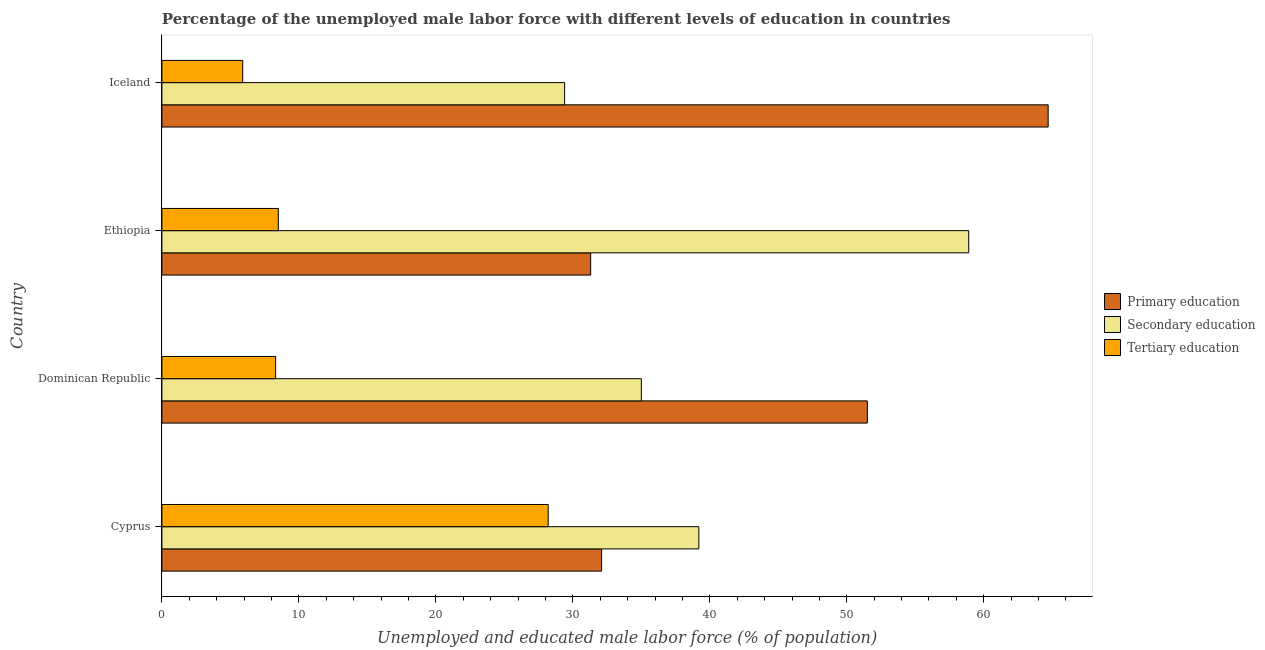How many different coloured bars are there?
Give a very brief answer. 3. How many groups of bars are there?
Give a very brief answer. 4. What is the label of the 3rd group of bars from the top?
Make the answer very short. Dominican Republic. In how many cases, is the number of bars for a given country not equal to the number of legend labels?
Your answer should be very brief. 0. What is the percentage of male labor force who received tertiary education in Dominican Republic?
Offer a very short reply. 8.3. Across all countries, what is the maximum percentage of male labor force who received primary education?
Offer a terse response. 64.7. Across all countries, what is the minimum percentage of male labor force who received tertiary education?
Provide a succinct answer. 5.9. In which country was the percentage of male labor force who received tertiary education maximum?
Your answer should be compact. Cyprus. In which country was the percentage of male labor force who received primary education minimum?
Your answer should be very brief. Ethiopia. What is the total percentage of male labor force who received tertiary education in the graph?
Provide a short and direct response. 50.9. What is the difference between the percentage of male labor force who received secondary education in Dominican Republic and the percentage of male labor force who received primary education in Cyprus?
Make the answer very short. 2.9. What is the average percentage of male labor force who received tertiary education per country?
Your answer should be compact. 12.72. In how many countries, is the percentage of male labor force who received secondary education greater than 10 %?
Your answer should be very brief. 4. What is the difference between the highest and the second highest percentage of male labor force who received secondary education?
Offer a very short reply. 19.7. What is the difference between the highest and the lowest percentage of male labor force who received primary education?
Ensure brevity in your answer.  33.4. What does the 2nd bar from the top in Ethiopia represents?
Your response must be concise. Secondary education. Is it the case that in every country, the sum of the percentage of male labor force who received primary education and percentage of male labor force who received secondary education is greater than the percentage of male labor force who received tertiary education?
Provide a short and direct response. Yes. How many countries are there in the graph?
Provide a short and direct response. 4. Where does the legend appear in the graph?
Make the answer very short. Center right. How are the legend labels stacked?
Your answer should be compact. Vertical. What is the title of the graph?
Ensure brevity in your answer.  Percentage of the unemployed male labor force with different levels of education in countries. Does "Food" appear as one of the legend labels in the graph?
Provide a short and direct response. No. What is the label or title of the X-axis?
Offer a terse response. Unemployed and educated male labor force (% of population). What is the Unemployed and educated male labor force (% of population) in Primary education in Cyprus?
Provide a succinct answer. 32.1. What is the Unemployed and educated male labor force (% of population) in Secondary education in Cyprus?
Your answer should be very brief. 39.2. What is the Unemployed and educated male labor force (% of population) in Tertiary education in Cyprus?
Your answer should be compact. 28.2. What is the Unemployed and educated male labor force (% of population) in Primary education in Dominican Republic?
Offer a very short reply. 51.5. What is the Unemployed and educated male labor force (% of population) of Tertiary education in Dominican Republic?
Provide a short and direct response. 8.3. What is the Unemployed and educated male labor force (% of population) of Primary education in Ethiopia?
Ensure brevity in your answer.  31.3. What is the Unemployed and educated male labor force (% of population) in Secondary education in Ethiopia?
Provide a short and direct response. 58.9. What is the Unemployed and educated male labor force (% of population) of Primary education in Iceland?
Offer a very short reply. 64.7. What is the Unemployed and educated male labor force (% of population) of Secondary education in Iceland?
Offer a terse response. 29.4. What is the Unemployed and educated male labor force (% of population) of Tertiary education in Iceland?
Offer a very short reply. 5.9. Across all countries, what is the maximum Unemployed and educated male labor force (% of population) in Primary education?
Give a very brief answer. 64.7. Across all countries, what is the maximum Unemployed and educated male labor force (% of population) in Secondary education?
Your answer should be compact. 58.9. Across all countries, what is the maximum Unemployed and educated male labor force (% of population) of Tertiary education?
Offer a terse response. 28.2. Across all countries, what is the minimum Unemployed and educated male labor force (% of population) in Primary education?
Provide a short and direct response. 31.3. Across all countries, what is the minimum Unemployed and educated male labor force (% of population) in Secondary education?
Keep it short and to the point. 29.4. Across all countries, what is the minimum Unemployed and educated male labor force (% of population) in Tertiary education?
Make the answer very short. 5.9. What is the total Unemployed and educated male labor force (% of population) of Primary education in the graph?
Provide a short and direct response. 179.6. What is the total Unemployed and educated male labor force (% of population) of Secondary education in the graph?
Ensure brevity in your answer.  162.5. What is the total Unemployed and educated male labor force (% of population) in Tertiary education in the graph?
Your answer should be very brief. 50.9. What is the difference between the Unemployed and educated male labor force (% of population) in Primary education in Cyprus and that in Dominican Republic?
Provide a succinct answer. -19.4. What is the difference between the Unemployed and educated male labor force (% of population) in Secondary education in Cyprus and that in Dominican Republic?
Make the answer very short. 4.2. What is the difference between the Unemployed and educated male labor force (% of population) of Secondary education in Cyprus and that in Ethiopia?
Make the answer very short. -19.7. What is the difference between the Unemployed and educated male labor force (% of population) in Tertiary education in Cyprus and that in Ethiopia?
Provide a succinct answer. 19.7. What is the difference between the Unemployed and educated male labor force (% of population) in Primary education in Cyprus and that in Iceland?
Offer a very short reply. -32.6. What is the difference between the Unemployed and educated male labor force (% of population) of Tertiary education in Cyprus and that in Iceland?
Give a very brief answer. 22.3. What is the difference between the Unemployed and educated male labor force (% of population) in Primary education in Dominican Republic and that in Ethiopia?
Your answer should be compact. 20.2. What is the difference between the Unemployed and educated male labor force (% of population) of Secondary education in Dominican Republic and that in Ethiopia?
Offer a very short reply. -23.9. What is the difference between the Unemployed and educated male labor force (% of population) of Primary education in Dominican Republic and that in Iceland?
Your answer should be very brief. -13.2. What is the difference between the Unemployed and educated male labor force (% of population) of Primary education in Ethiopia and that in Iceland?
Your answer should be compact. -33.4. What is the difference between the Unemployed and educated male labor force (% of population) of Secondary education in Ethiopia and that in Iceland?
Give a very brief answer. 29.5. What is the difference between the Unemployed and educated male labor force (% of population) of Tertiary education in Ethiopia and that in Iceland?
Your answer should be compact. 2.6. What is the difference between the Unemployed and educated male labor force (% of population) in Primary education in Cyprus and the Unemployed and educated male labor force (% of population) in Tertiary education in Dominican Republic?
Ensure brevity in your answer.  23.8. What is the difference between the Unemployed and educated male labor force (% of population) in Secondary education in Cyprus and the Unemployed and educated male labor force (% of population) in Tertiary education in Dominican Republic?
Make the answer very short. 30.9. What is the difference between the Unemployed and educated male labor force (% of population) of Primary education in Cyprus and the Unemployed and educated male labor force (% of population) of Secondary education in Ethiopia?
Your answer should be very brief. -26.8. What is the difference between the Unemployed and educated male labor force (% of population) of Primary education in Cyprus and the Unemployed and educated male labor force (% of population) of Tertiary education in Ethiopia?
Your response must be concise. 23.6. What is the difference between the Unemployed and educated male labor force (% of population) in Secondary education in Cyprus and the Unemployed and educated male labor force (% of population) in Tertiary education in Ethiopia?
Offer a terse response. 30.7. What is the difference between the Unemployed and educated male labor force (% of population) of Primary education in Cyprus and the Unemployed and educated male labor force (% of population) of Secondary education in Iceland?
Provide a succinct answer. 2.7. What is the difference between the Unemployed and educated male labor force (% of population) of Primary education in Cyprus and the Unemployed and educated male labor force (% of population) of Tertiary education in Iceland?
Provide a short and direct response. 26.2. What is the difference between the Unemployed and educated male labor force (% of population) in Secondary education in Cyprus and the Unemployed and educated male labor force (% of population) in Tertiary education in Iceland?
Keep it short and to the point. 33.3. What is the difference between the Unemployed and educated male labor force (% of population) in Primary education in Dominican Republic and the Unemployed and educated male labor force (% of population) in Tertiary education in Ethiopia?
Give a very brief answer. 43. What is the difference between the Unemployed and educated male labor force (% of population) of Primary education in Dominican Republic and the Unemployed and educated male labor force (% of population) of Secondary education in Iceland?
Offer a very short reply. 22.1. What is the difference between the Unemployed and educated male labor force (% of population) in Primary education in Dominican Republic and the Unemployed and educated male labor force (% of population) in Tertiary education in Iceland?
Your answer should be compact. 45.6. What is the difference between the Unemployed and educated male labor force (% of population) in Secondary education in Dominican Republic and the Unemployed and educated male labor force (% of population) in Tertiary education in Iceland?
Your answer should be compact. 29.1. What is the difference between the Unemployed and educated male labor force (% of population) of Primary education in Ethiopia and the Unemployed and educated male labor force (% of population) of Secondary education in Iceland?
Your answer should be very brief. 1.9. What is the difference between the Unemployed and educated male labor force (% of population) of Primary education in Ethiopia and the Unemployed and educated male labor force (% of population) of Tertiary education in Iceland?
Offer a very short reply. 25.4. What is the difference between the Unemployed and educated male labor force (% of population) in Secondary education in Ethiopia and the Unemployed and educated male labor force (% of population) in Tertiary education in Iceland?
Provide a succinct answer. 53. What is the average Unemployed and educated male labor force (% of population) in Primary education per country?
Your answer should be very brief. 44.9. What is the average Unemployed and educated male labor force (% of population) in Secondary education per country?
Provide a short and direct response. 40.62. What is the average Unemployed and educated male labor force (% of population) in Tertiary education per country?
Make the answer very short. 12.72. What is the difference between the Unemployed and educated male labor force (% of population) of Secondary education and Unemployed and educated male labor force (% of population) of Tertiary education in Cyprus?
Your response must be concise. 11. What is the difference between the Unemployed and educated male labor force (% of population) of Primary education and Unemployed and educated male labor force (% of population) of Tertiary education in Dominican Republic?
Give a very brief answer. 43.2. What is the difference between the Unemployed and educated male labor force (% of population) of Secondary education and Unemployed and educated male labor force (% of population) of Tertiary education in Dominican Republic?
Provide a succinct answer. 26.7. What is the difference between the Unemployed and educated male labor force (% of population) in Primary education and Unemployed and educated male labor force (% of population) in Secondary education in Ethiopia?
Provide a succinct answer. -27.6. What is the difference between the Unemployed and educated male labor force (% of population) of Primary education and Unemployed and educated male labor force (% of population) of Tertiary education in Ethiopia?
Provide a succinct answer. 22.8. What is the difference between the Unemployed and educated male labor force (% of population) in Secondary education and Unemployed and educated male labor force (% of population) in Tertiary education in Ethiopia?
Your answer should be very brief. 50.4. What is the difference between the Unemployed and educated male labor force (% of population) in Primary education and Unemployed and educated male labor force (% of population) in Secondary education in Iceland?
Offer a terse response. 35.3. What is the difference between the Unemployed and educated male labor force (% of population) of Primary education and Unemployed and educated male labor force (% of population) of Tertiary education in Iceland?
Your response must be concise. 58.8. What is the difference between the Unemployed and educated male labor force (% of population) of Secondary education and Unemployed and educated male labor force (% of population) of Tertiary education in Iceland?
Keep it short and to the point. 23.5. What is the ratio of the Unemployed and educated male labor force (% of population) of Primary education in Cyprus to that in Dominican Republic?
Give a very brief answer. 0.62. What is the ratio of the Unemployed and educated male labor force (% of population) of Secondary education in Cyprus to that in Dominican Republic?
Provide a succinct answer. 1.12. What is the ratio of the Unemployed and educated male labor force (% of population) in Tertiary education in Cyprus to that in Dominican Republic?
Keep it short and to the point. 3.4. What is the ratio of the Unemployed and educated male labor force (% of population) of Primary education in Cyprus to that in Ethiopia?
Your response must be concise. 1.03. What is the ratio of the Unemployed and educated male labor force (% of population) in Secondary education in Cyprus to that in Ethiopia?
Offer a terse response. 0.67. What is the ratio of the Unemployed and educated male labor force (% of population) in Tertiary education in Cyprus to that in Ethiopia?
Ensure brevity in your answer.  3.32. What is the ratio of the Unemployed and educated male labor force (% of population) of Primary education in Cyprus to that in Iceland?
Ensure brevity in your answer.  0.5. What is the ratio of the Unemployed and educated male labor force (% of population) in Secondary education in Cyprus to that in Iceland?
Offer a very short reply. 1.33. What is the ratio of the Unemployed and educated male labor force (% of population) in Tertiary education in Cyprus to that in Iceland?
Give a very brief answer. 4.78. What is the ratio of the Unemployed and educated male labor force (% of population) of Primary education in Dominican Republic to that in Ethiopia?
Provide a succinct answer. 1.65. What is the ratio of the Unemployed and educated male labor force (% of population) in Secondary education in Dominican Republic to that in Ethiopia?
Provide a succinct answer. 0.59. What is the ratio of the Unemployed and educated male labor force (% of population) in Tertiary education in Dominican Republic to that in Ethiopia?
Your answer should be very brief. 0.98. What is the ratio of the Unemployed and educated male labor force (% of population) in Primary education in Dominican Republic to that in Iceland?
Ensure brevity in your answer.  0.8. What is the ratio of the Unemployed and educated male labor force (% of population) of Secondary education in Dominican Republic to that in Iceland?
Make the answer very short. 1.19. What is the ratio of the Unemployed and educated male labor force (% of population) in Tertiary education in Dominican Republic to that in Iceland?
Offer a very short reply. 1.41. What is the ratio of the Unemployed and educated male labor force (% of population) in Primary education in Ethiopia to that in Iceland?
Ensure brevity in your answer.  0.48. What is the ratio of the Unemployed and educated male labor force (% of population) in Secondary education in Ethiopia to that in Iceland?
Make the answer very short. 2. What is the ratio of the Unemployed and educated male labor force (% of population) in Tertiary education in Ethiopia to that in Iceland?
Make the answer very short. 1.44. What is the difference between the highest and the second highest Unemployed and educated male labor force (% of population) of Secondary education?
Provide a short and direct response. 19.7. What is the difference between the highest and the lowest Unemployed and educated male labor force (% of population) in Primary education?
Make the answer very short. 33.4. What is the difference between the highest and the lowest Unemployed and educated male labor force (% of population) of Secondary education?
Give a very brief answer. 29.5. What is the difference between the highest and the lowest Unemployed and educated male labor force (% of population) of Tertiary education?
Offer a terse response. 22.3. 